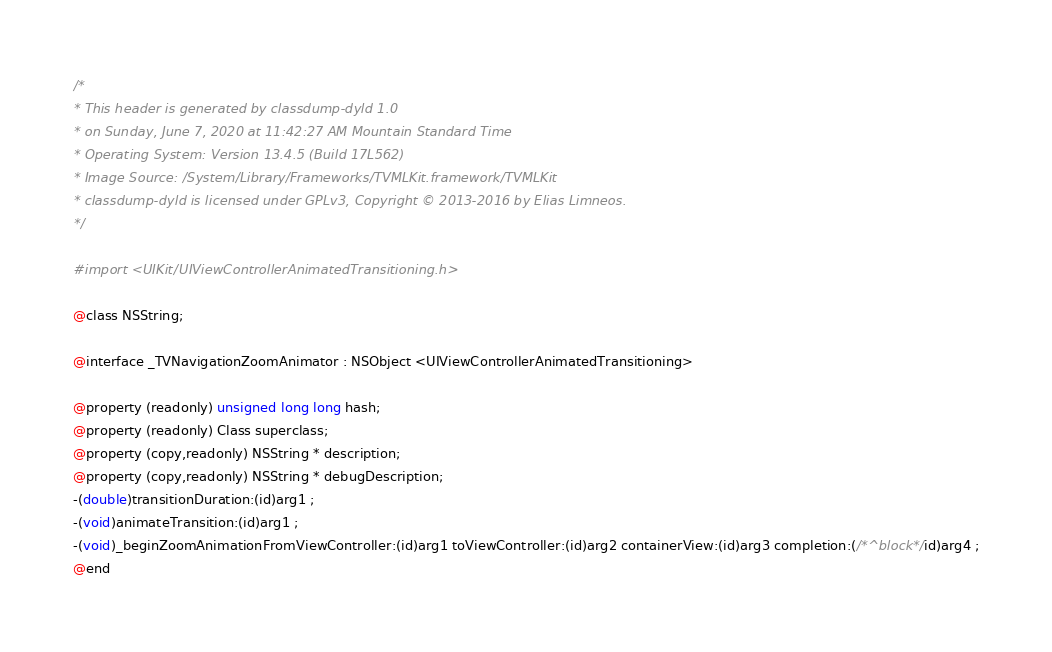<code> <loc_0><loc_0><loc_500><loc_500><_C_>/*
* This header is generated by classdump-dyld 1.0
* on Sunday, June 7, 2020 at 11:42:27 AM Mountain Standard Time
* Operating System: Version 13.4.5 (Build 17L562)
* Image Source: /System/Library/Frameworks/TVMLKit.framework/TVMLKit
* classdump-dyld is licensed under GPLv3, Copyright © 2013-2016 by Elias Limneos.
*/

#import <UIKit/UIViewControllerAnimatedTransitioning.h>

@class NSString;

@interface _TVNavigationZoomAnimator : NSObject <UIViewControllerAnimatedTransitioning>

@property (readonly) unsigned long long hash; 
@property (readonly) Class superclass; 
@property (copy,readonly) NSString * description; 
@property (copy,readonly) NSString * debugDescription; 
-(double)transitionDuration:(id)arg1 ;
-(void)animateTransition:(id)arg1 ;
-(void)_beginZoomAnimationFromViewController:(id)arg1 toViewController:(id)arg2 containerView:(id)arg3 completion:(/*^block*/id)arg4 ;
@end

</code> 